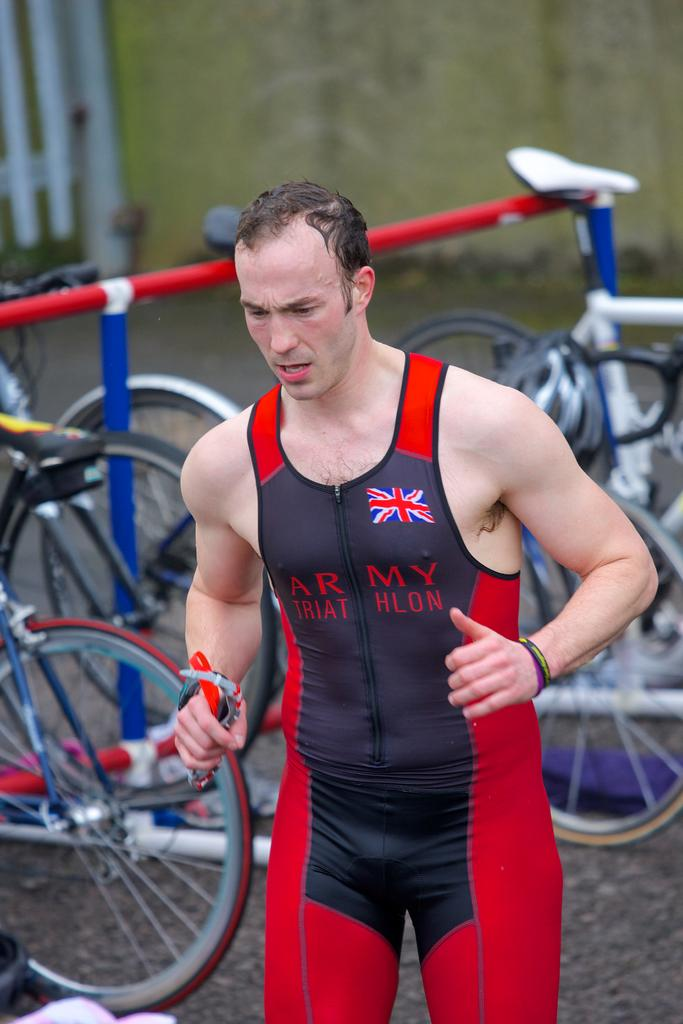<image>
Share a concise interpretation of the image provided. A man wearing red and blue army triathlon bike tights is walking away from the bikes. 